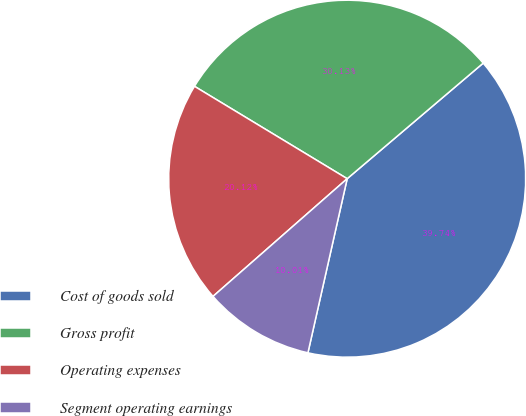<chart> <loc_0><loc_0><loc_500><loc_500><pie_chart><fcel>Cost of goods sold<fcel>Gross profit<fcel>Operating expenses<fcel>Segment operating earnings<nl><fcel>39.74%<fcel>30.13%<fcel>20.12%<fcel>10.01%<nl></chart> 